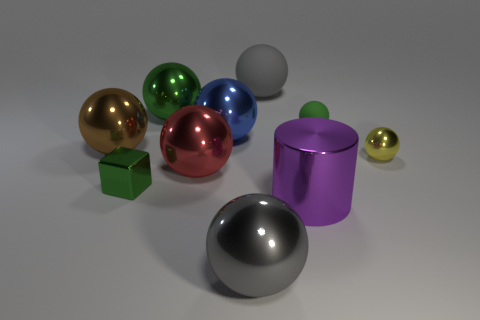There is a small sphere that is the same color as the tiny shiny cube; what is its material?
Your answer should be compact. Rubber. Does the large gray sphere that is behind the big brown sphere have the same material as the brown thing in front of the large green ball?
Offer a terse response. No. Is there a blue sphere?
Provide a short and direct response. Yes. Are there more big brown metal balls that are left of the green rubber sphere than big blue metallic balls right of the big purple object?
Make the answer very short. Yes. There is a big blue thing that is the same shape as the small matte object; what is its material?
Ensure brevity in your answer.  Metal. Is there any other thing that has the same size as the green block?
Your answer should be very brief. Yes. There is a tiny metal object that is to the right of the purple thing; is it the same color as the metallic object that is to the left of the block?
Your answer should be compact. No. The tiny green matte object is what shape?
Your answer should be compact. Sphere. Is the number of tiny yellow metallic objects that are in front of the green matte thing greater than the number of big cyan matte objects?
Provide a short and direct response. Yes. There is a tiny green object that is behind the brown sphere; what is its shape?
Make the answer very short. Sphere. 